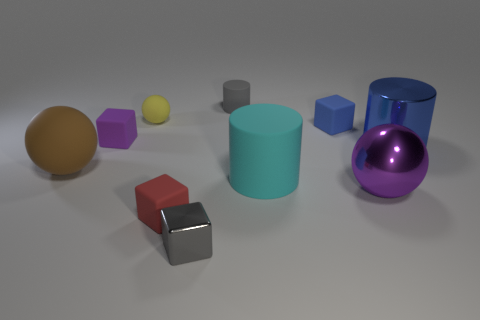There is a gray shiny block; what number of big metal objects are to the left of it?
Give a very brief answer. 0. There is a cylinder behind the large object behind the large rubber thing that is to the left of the yellow matte object; what size is it?
Keep it short and to the point. Small. Are there any tiny blue blocks that are behind the big shiny object that is behind the large matte thing on the right side of the purple rubber block?
Ensure brevity in your answer.  Yes. Is the number of yellow things greater than the number of large cylinders?
Make the answer very short. No. The large cylinder in front of the brown matte sphere is what color?
Make the answer very short. Cyan. Is the number of blue matte blocks in front of the big brown rubber ball greater than the number of small cubes?
Make the answer very short. No. Is the material of the gray cylinder the same as the purple sphere?
Give a very brief answer. No. What number of other objects are there of the same shape as the yellow rubber object?
Keep it short and to the point. 2. There is a matte ball that is left of the rubber block that is left of the rubber ball that is right of the brown rubber ball; what color is it?
Make the answer very short. Brown. There is a purple object on the left side of the gray metallic cube; does it have the same shape as the yellow thing?
Provide a succinct answer. No. 